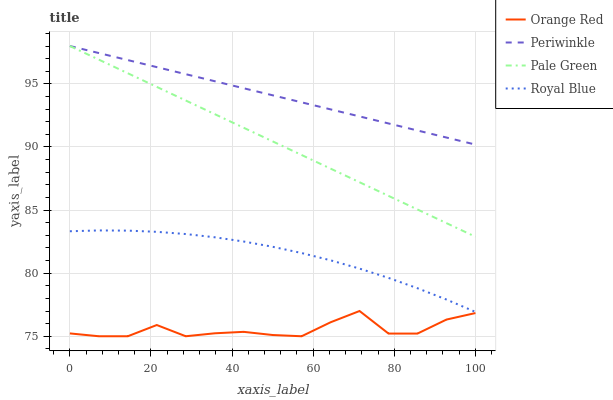Does Orange Red have the minimum area under the curve?
Answer yes or no. Yes. Does Periwinkle have the maximum area under the curve?
Answer yes or no. Yes. Does Pale Green have the minimum area under the curve?
Answer yes or no. No. Does Pale Green have the maximum area under the curve?
Answer yes or no. No. Is Pale Green the smoothest?
Answer yes or no. Yes. Is Orange Red the roughest?
Answer yes or no. Yes. Is Periwinkle the smoothest?
Answer yes or no. No. Is Periwinkle the roughest?
Answer yes or no. No. Does Orange Red have the lowest value?
Answer yes or no. Yes. Does Pale Green have the lowest value?
Answer yes or no. No. Does Periwinkle have the highest value?
Answer yes or no. Yes. Does Orange Red have the highest value?
Answer yes or no. No. Is Royal Blue less than Periwinkle?
Answer yes or no. Yes. Is Pale Green greater than Orange Red?
Answer yes or no. Yes. Does Periwinkle intersect Pale Green?
Answer yes or no. Yes. Is Periwinkle less than Pale Green?
Answer yes or no. No. Is Periwinkle greater than Pale Green?
Answer yes or no. No. Does Royal Blue intersect Periwinkle?
Answer yes or no. No. 